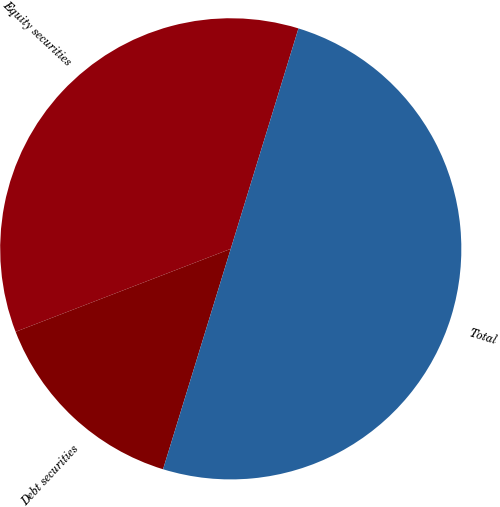Convert chart. <chart><loc_0><loc_0><loc_500><loc_500><pie_chart><fcel>Equity securities<fcel>Debt securities<fcel>Total<nl><fcel>35.6%<fcel>14.4%<fcel>50.0%<nl></chart> 